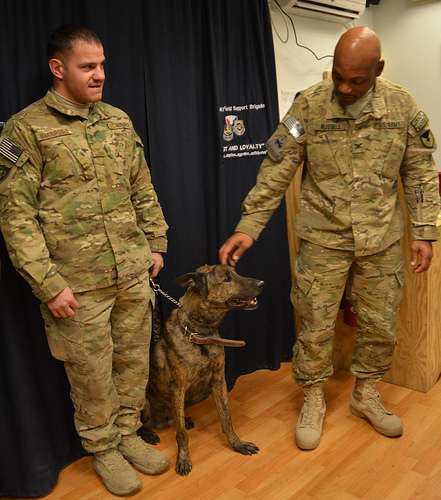<image>
Is the dog behind the man? No. The dog is not behind the man. From this viewpoint, the dog appears to be positioned elsewhere in the scene. 